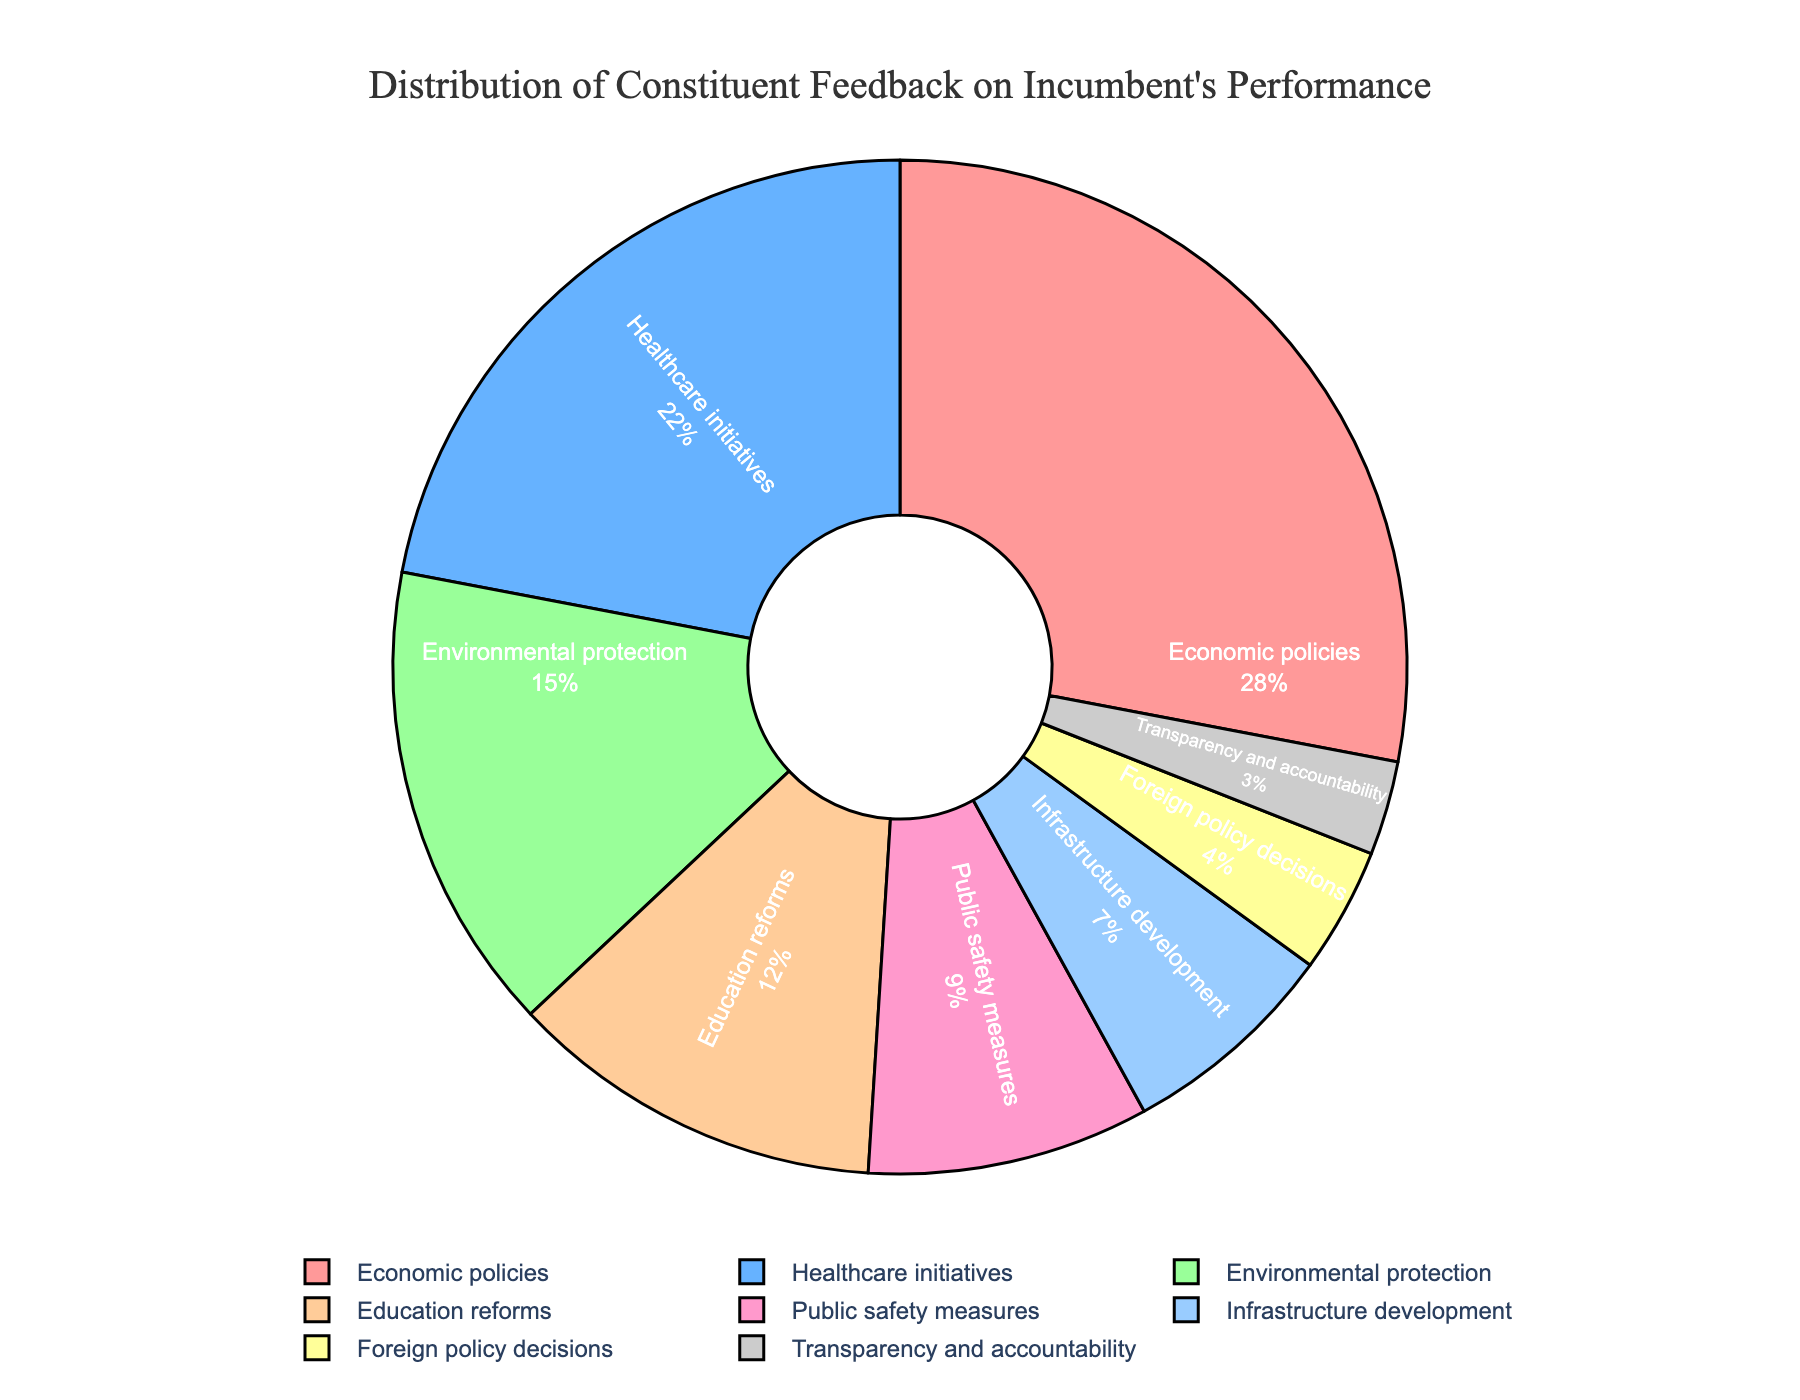Which category received the highest percentage of feedback? To determine which category received the highest percentage of feedback, look for the category with the largest slice of the pie chart and the highest percentage label. In this case, "Economic policies" has the highest percentage at 28%.
Answer: Economic policies What is the combined percentage of feedback for Healthcare initiatives and Education reforms? Add the percentages of Healthcare initiatives and Education reforms. Healthcare initiatives have 22% and Education reforms have 12%. Thus, the combined percentage is 22% + 12% = 34%.
Answer: 34% Which category has a smaller percentage of feedback: Foreign policy decisions or Transparency and accountability? Compare the percentages of the two categories. Foreign policy decisions have 4%, while Transparency and accountability have 3%. Therefore, Transparency and accountability have a smaller percentage.
Answer: Transparency and accountability What is the total feedback percentage for Economic policies, Healthcare initiatives, and Environmental protection combined? Sum the percentages of Economic policies, Healthcare initiatives, and Environmental protection. Economic policies are 28%, Healthcare initiatives are 22%, and Environmental protection is 15%. Therefore, the combined total is 28% + 22% + 15% = 65%.
Answer: 65% What percentage of feedback did Infrastructure development receive and what color is its slice in the pie chart? Look for the label "Infrastructure development" in the pie chart to find its percentage and slice color. Infrastructure development received 7% and its slice is colored with the code '#99CCFF', which is generally a light blue shade.
Answer: 7% and light blue Which categories together constitute less than 20% of the total feedback? Identify the categories with percentages individually less than 20%, then add their percentages to verify they sum to less than 20%. Transparency and accountability (3%) and Foreign policy decisions (4%) fulfill this.
Answer: Transparency and accountability, Foreign policy decisions By how much does the feedback percentage for Education reforms exceed that of Public safety measures? Subtract the percentage of Public safety measures from Education reforms. Education reforms have 12%, and Public safety measures have 9%. Thus, the difference is 12% - 9% = 3%.
Answer: 3% What is the feedback percentage given to Environmental protection and what is the visual marker for this category in the pie chart? Find the label "Environmental protection" in the pie chart to determine the feedback percentage and its color. Environmental protection received 15% and is marked with a green color.
Answer: 15% and green 